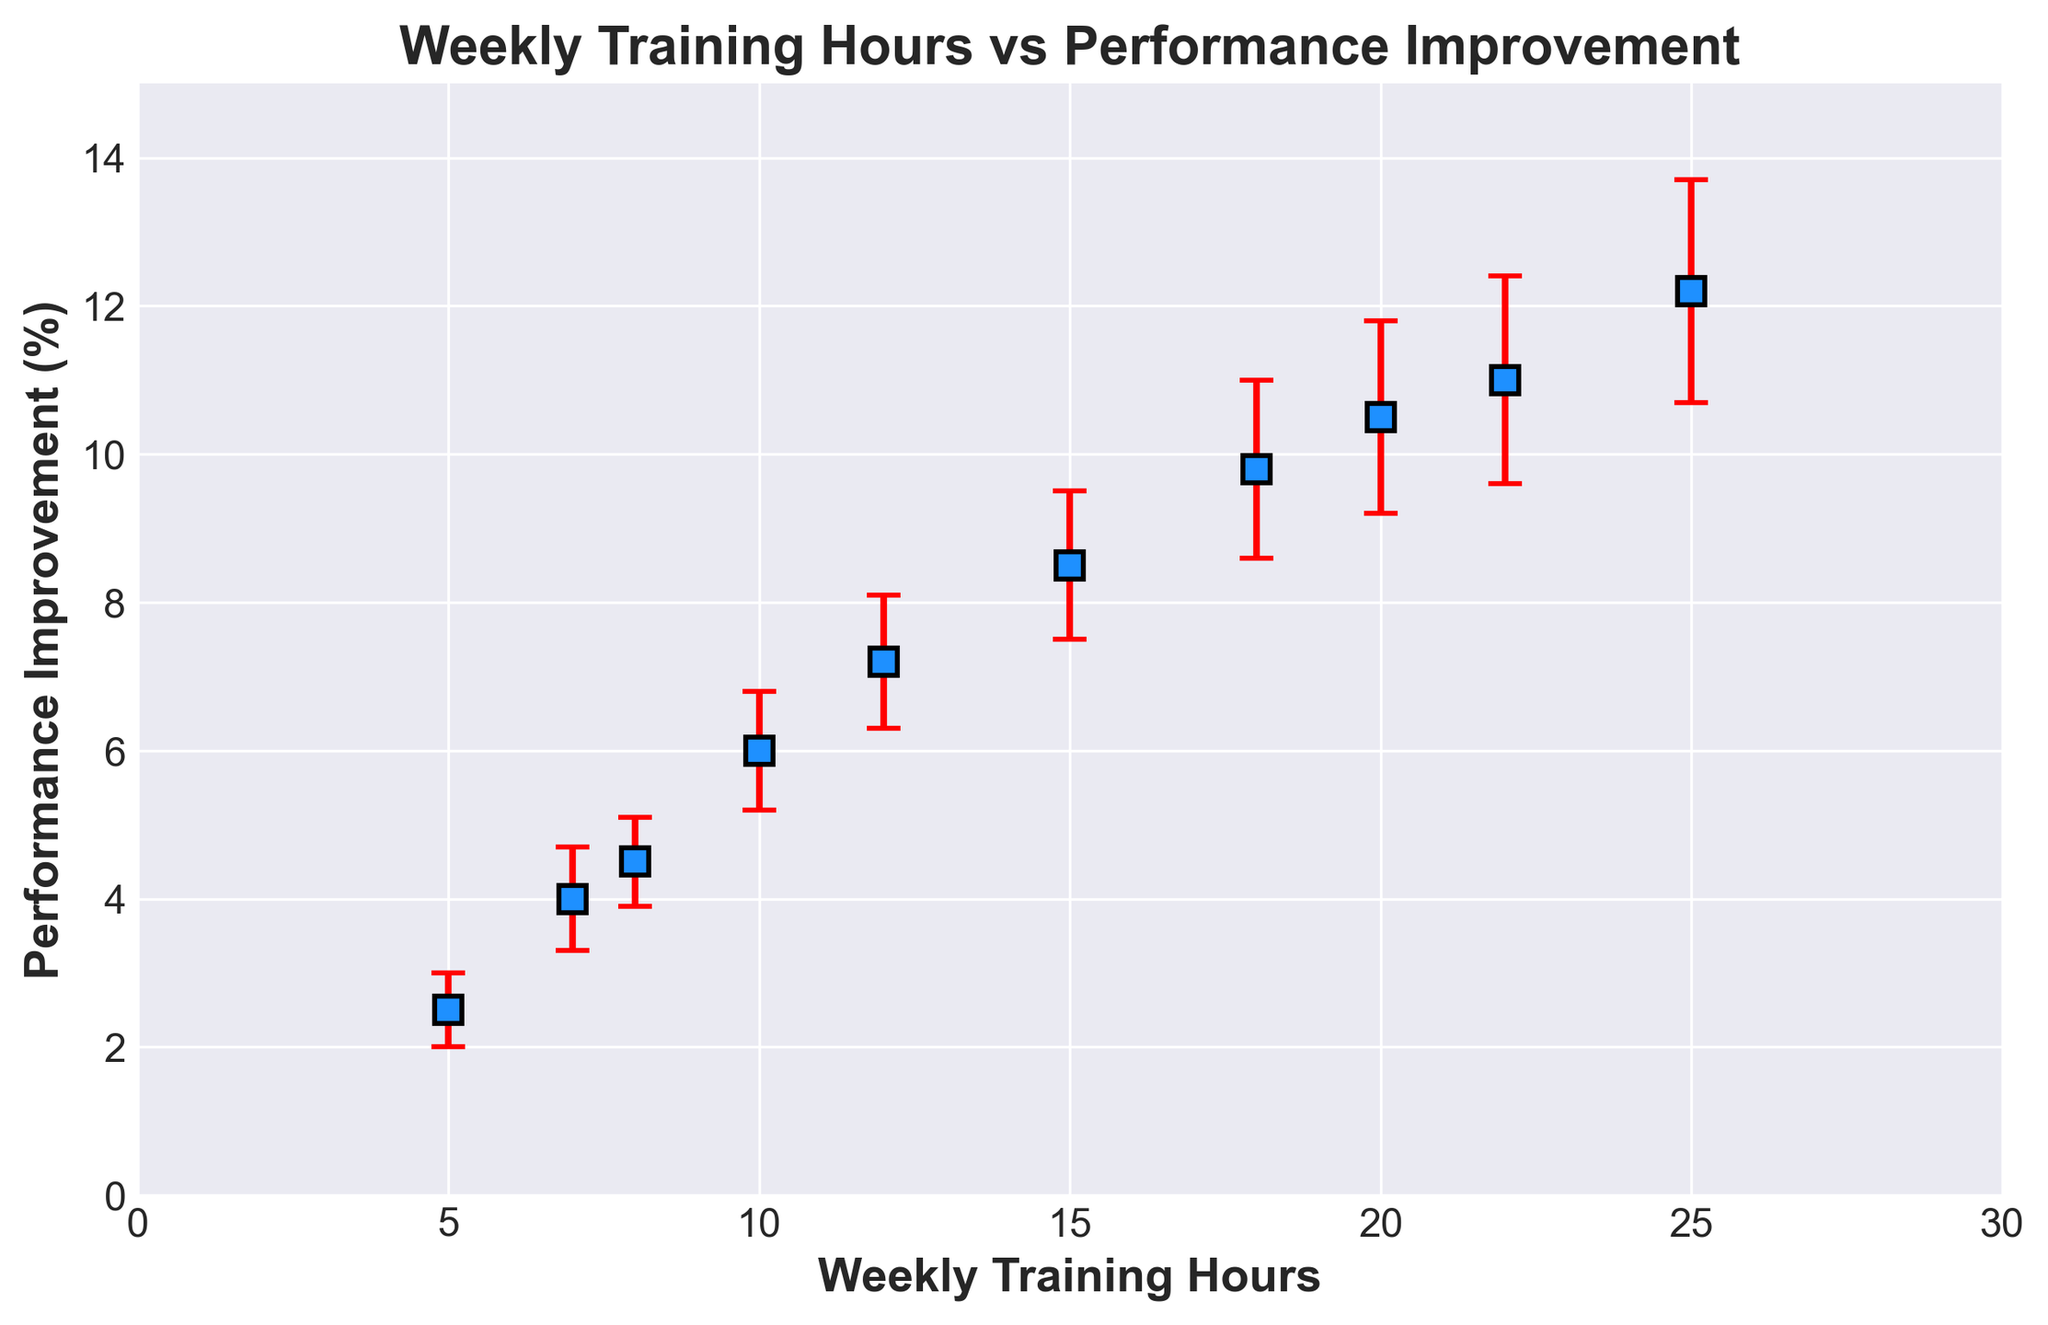What's the starting point of Performance Improvement for 5 weekly training hours? Look at the first data point on the x-axis, which corresponds to 5 weekly training hours, and note the performance improvement value.
Answer: 2.5% How much does Performance Improvement increase from 15 to 20 weekly training hours? Check the performance improvement for 15 hours (8.5%) and 20 hours (10.5%), then find the difference: 10.5% - 8.5%.
Answer: 2% What is the highest Performance Improvement value shown in the figure, and at how many weekly training hours does it occur? Identify the maximum value of Performance Improvement on the y-axis and note the corresponding x-axis value.
Answer: 12.2% at 25 hours What is the average Performance Improvement for weekly training hours at 10 and 15 respectively? Calculate the mean value by adding the performance improvement for 10 hours (6.0%) and 15 hours (8.5%) and dividing by 2: (6.0 + 8.5) / 2.
Answer: 7.25% Between which two weekly training hours does the largest increase in Performance Improvement occur? Compare the differences between successive points on the graph; the largest increase occurs between 20 and 25 hours (12.2% - 10.5%).
Answer: 20 to 25 hours What is the error range for the Performance Improvement at 7 weekly training hours? Check the provided error value for 7 training hours (±0.7%) and apply it to the performance improvement (4.0% + 0.7% and 4.0% - 0.7%).
Answer: 3.3% to 4.7% Is there a noticeable trend in the relationship between Weekly Training Hours and Performance Improvement? Observe the general shape of the plot; there is a positive correlation as performance improvement tends to increase with more training hours.
Answer: Yes, positive correlation How many weekly training hours are needed to achieve approximately 10% Performance Improvement? Find the data point closest to 10% on the y-axis and note the corresponding x-axis value (approximately between 18 and 20 hours).
Answer: 18-20 hours 